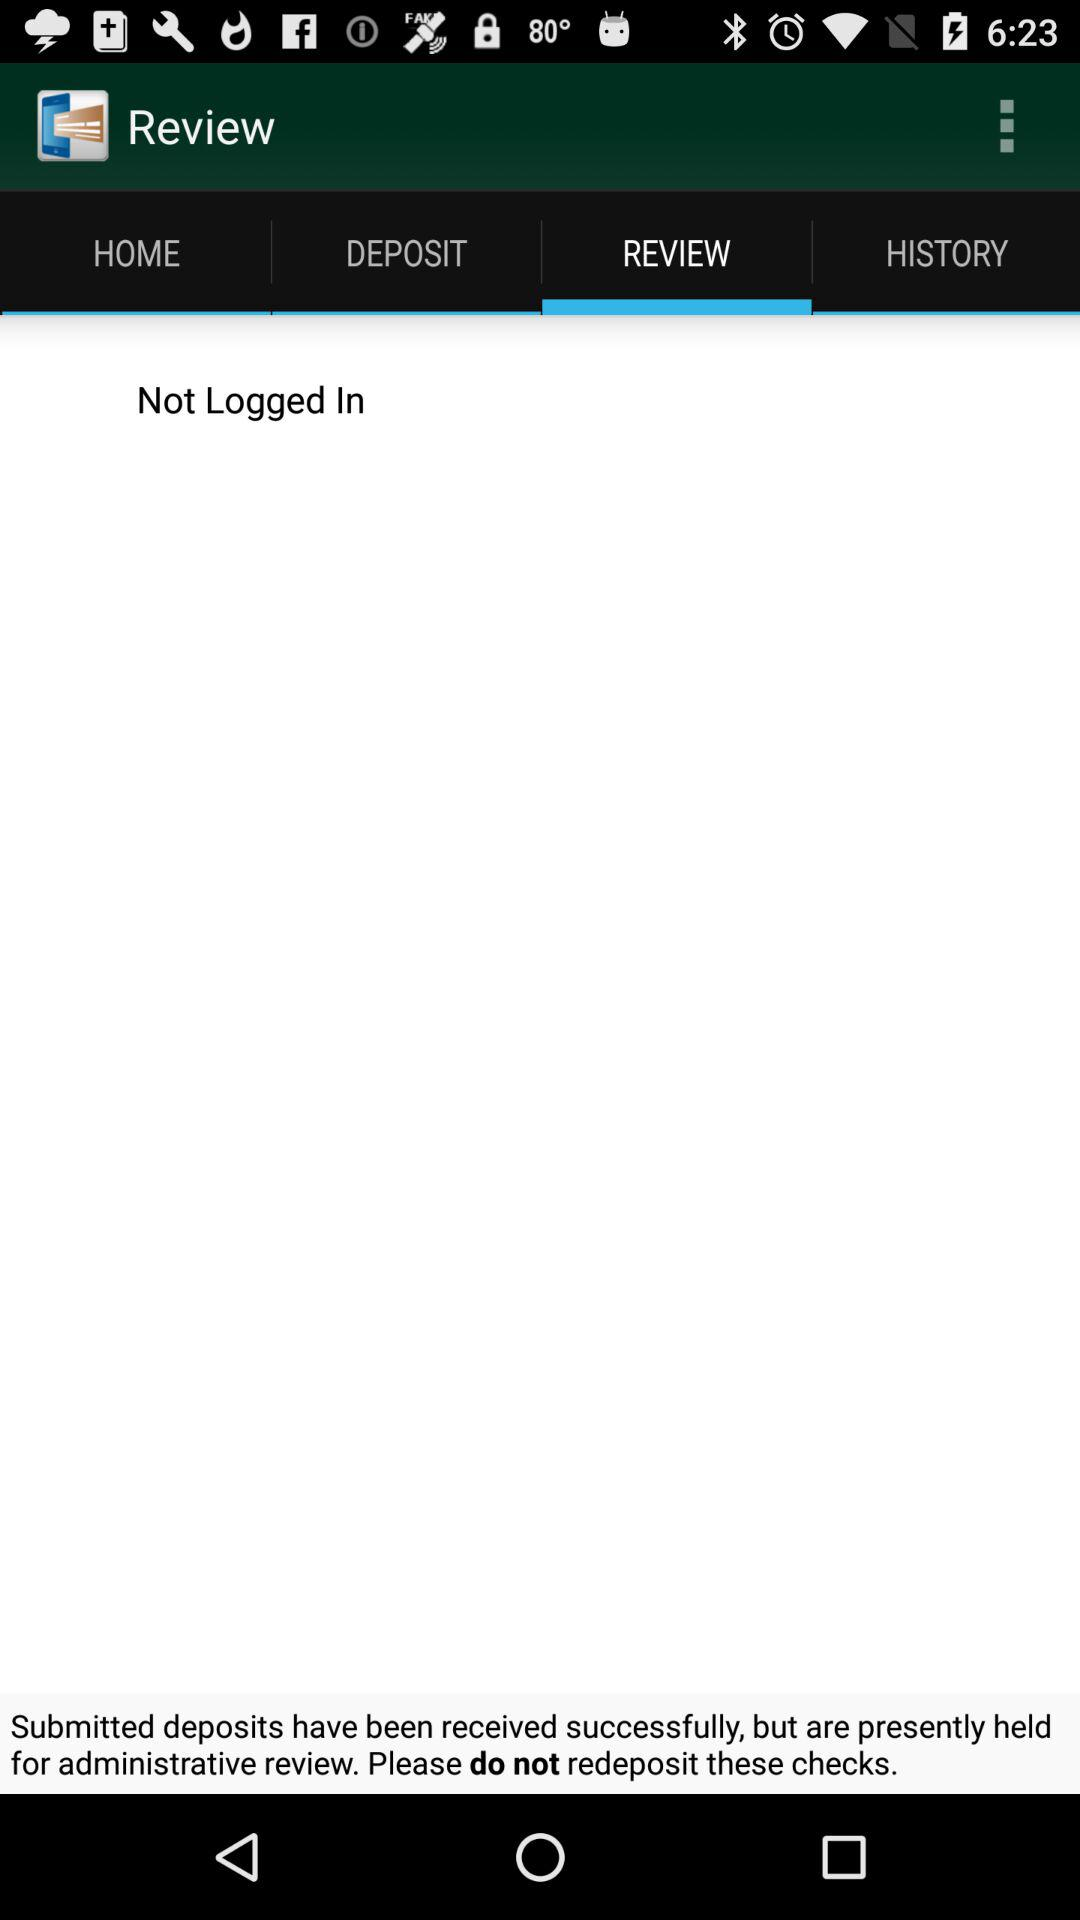Which tab am I on? You are on "REVIEW" tab. 